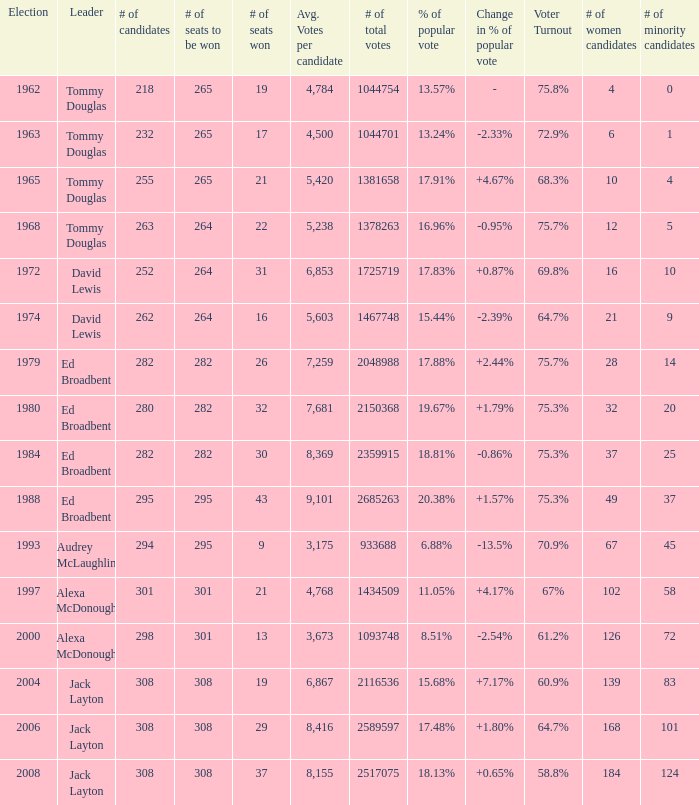Name the number of seats to be won being % of popular vote at 6.88% 295.0. 